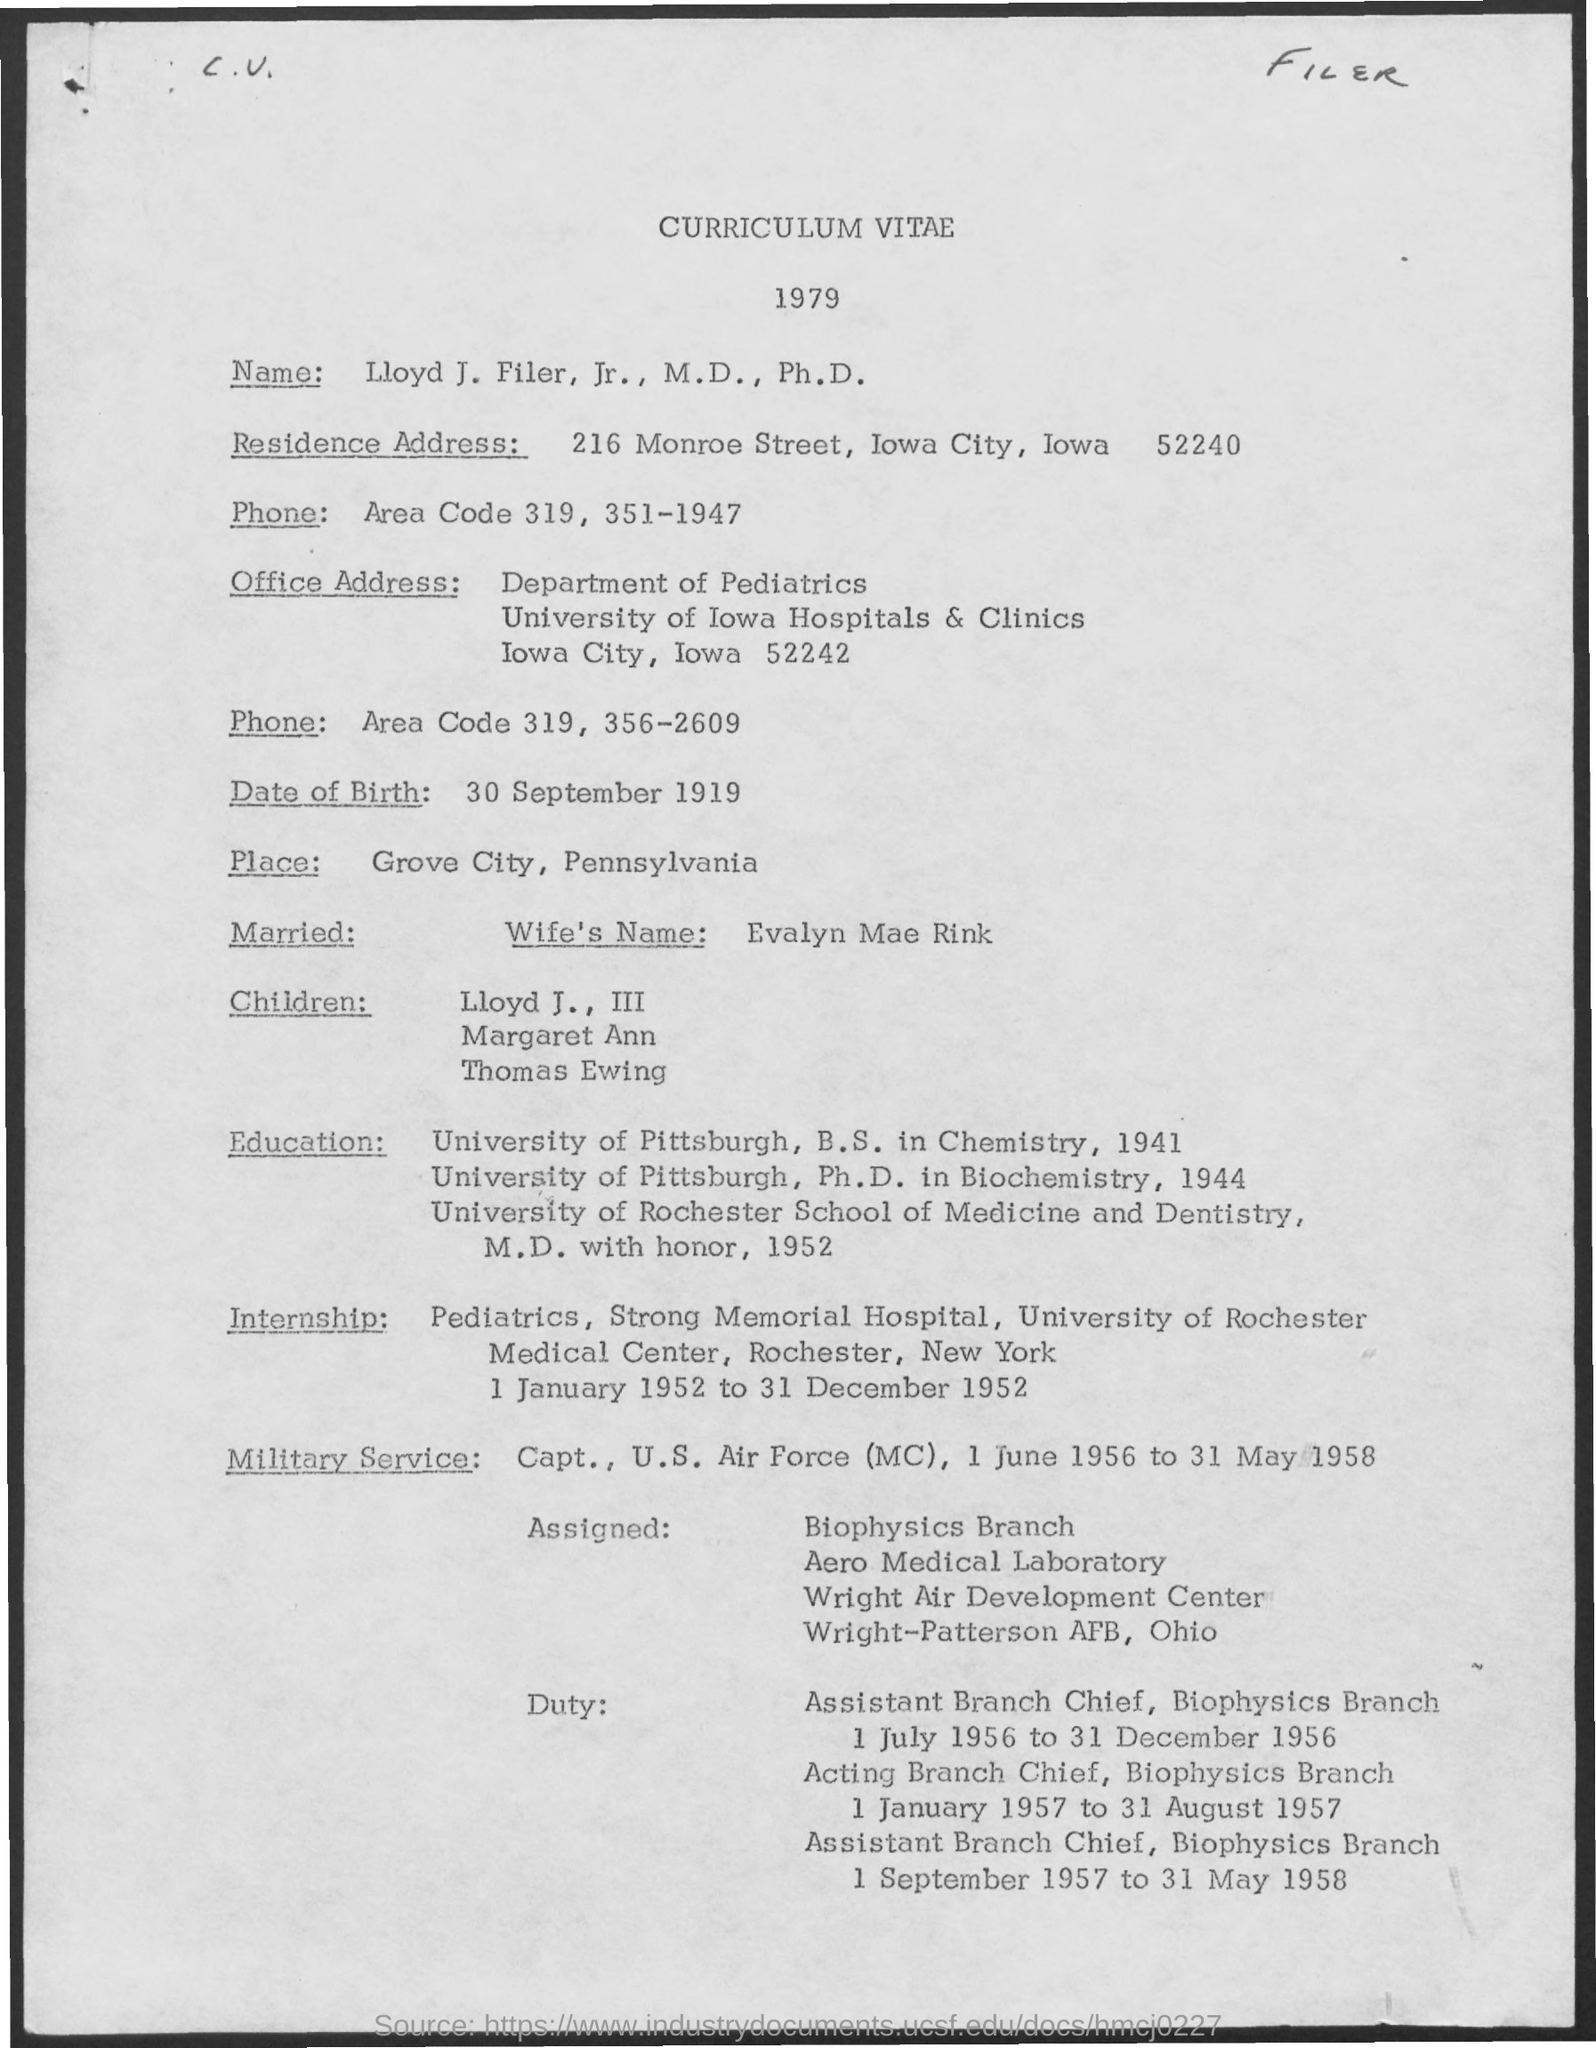What is the document about?
Ensure brevity in your answer.  Curriculum Vitae. Whose Curriculum Vitae is it?
Ensure brevity in your answer.  Lloyd J. Filer. What is the residence address?
Offer a very short reply. 216 Monroe Street, Iowa City, iowa 52240. What is date of birth ?
Provide a succinct answer. 30 september 1919. What is name of wife?
Provide a succinct answer. Evalyn Mae Rink. Which year was Curriculum Vitae made?
Give a very brief answer. 1979. 